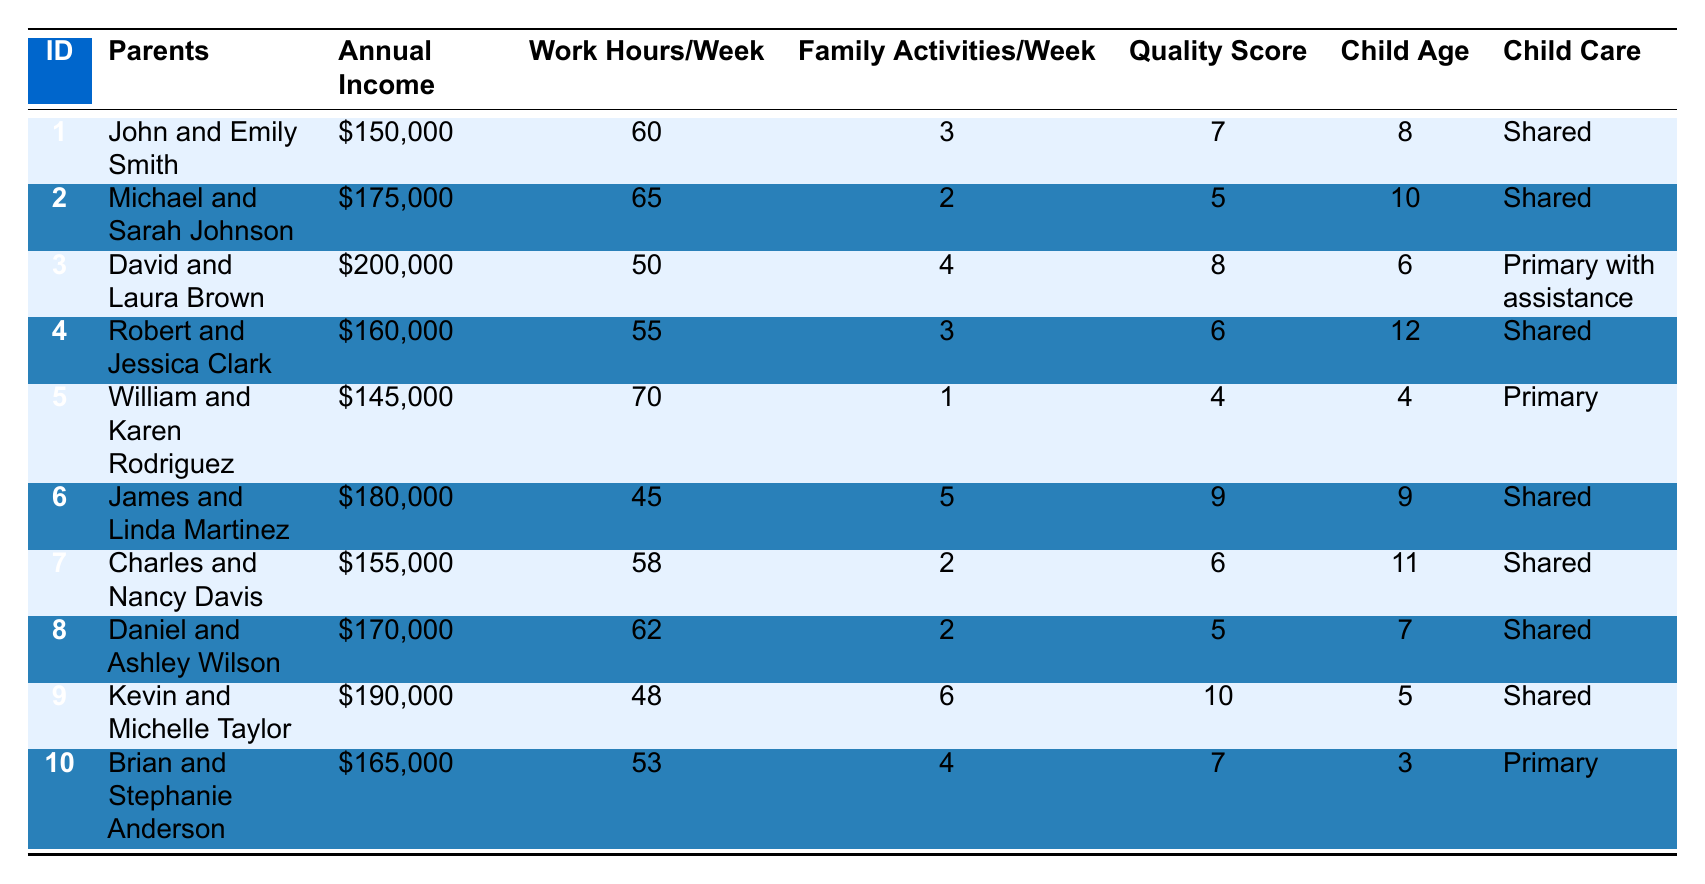What is the highest combined annual income among the households? Looking at the combined annual income column, the highest value listed is $200,000 from the household of David and Laura Brown.
Answer: $200,000 How many family activities do John and Emily Smith participate in per week? According to the table, John and Emily Smith participate in 3 family activities per week.
Answer: 3 What is the quality of family time score for the household with the youngest child? The household with the youngest child is William and Karen Rodriguez (age 4), with a quality score of 4.
Answer: 4 What is the average number of family activities per week across all households? To find the average, we sum the family activities (3+2+4+3+1+5+2+2+6+4 = 32) and divide by the number of households (10), giving an average of 3.2.
Answer: 3.2 Which household has the most work hours per week? By examining the work hours column, the household with the most work hours is William and Karen Rodriguez with 70 hours per week.
Answer: 70 Is there a correlation between higher work hours and a lower quality of family time score? To determine this, we would analyze the data. For instance, households like Michael and Sarah Johnson (65 hours, score 5) and William and Karen Rodriguez (70 hours, score 4) show lower quality with higher work hours, suggesting a trend.
Answer: Yes How many households have shared child care responsibilities? By counting the entries in the Child Care Responsibilities column, we find that 6 out of the 10 households have shared child care responsibilities.
Answer: 6 What is the average difference in quality of family time score between households with shared and primary child care responsibilities? The average score for shared is (7+5+8+6+9+10+5) = 50/7 = 7.14, and for primary it is (4+7) = 11/2 = 5.5. The difference is 7.14 - 5.5 = 1.64.
Answer: 1.64 Which household has the highest quality of family time score for those who have shared child care? Among households with shared child care responsibilities, the highest quality score is 10 from Kevin and Michelle Taylor.
Answer: 10 Do households with a higher combined annual income generally spend more time on family activities? Analyzing the data shows that higher income like $200,000 (David and Laura Brown with 4 activities) doesn’t always correlate; other high incomes (like $175,000 Michael and Sarah Johnson) have only 2 activities.
Answer: No 